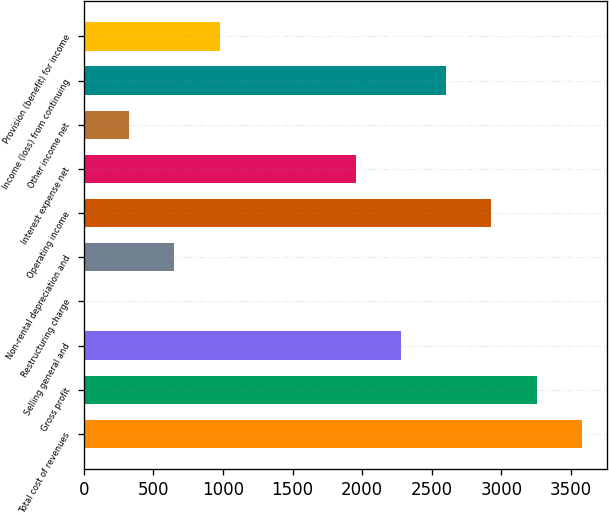Convert chart. <chart><loc_0><loc_0><loc_500><loc_500><bar_chart><fcel>Total cost of revenues<fcel>Gross profit<fcel>Selling general and<fcel>Restructuring charge<fcel>Non-rental depreciation and<fcel>Operating income<fcel>Interest expense net<fcel>Other income net<fcel>Income (loss) from continuing<fcel>Provision (benefit) for income<nl><fcel>3578.2<fcel>3253<fcel>2277.4<fcel>1<fcel>651.4<fcel>2927.8<fcel>1952.2<fcel>326.2<fcel>2602.6<fcel>976.6<nl></chart> 